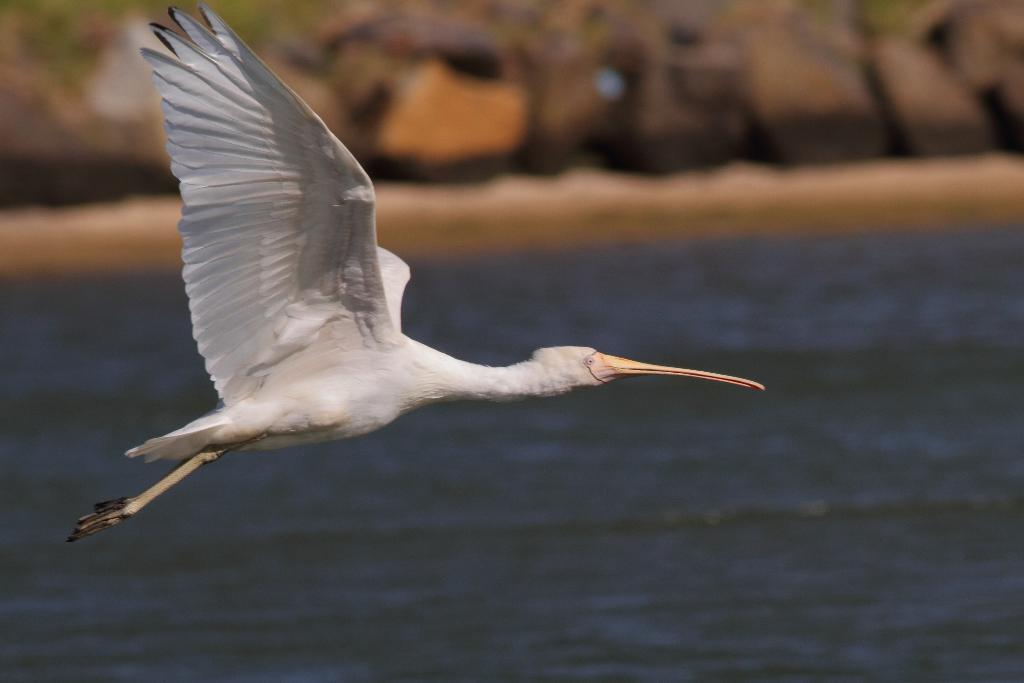What type of animal is in the image? There is a white color bird in the image. What is the bird doing in the image? The bird is flying in the air. What can be seen in the background of the image? There is water visible in the background of the image. How would you describe the background of the image? The background of the image is blurred. How does the bird kick the car in the image? There is no car present in the image, and therefore no such action can be observed. 